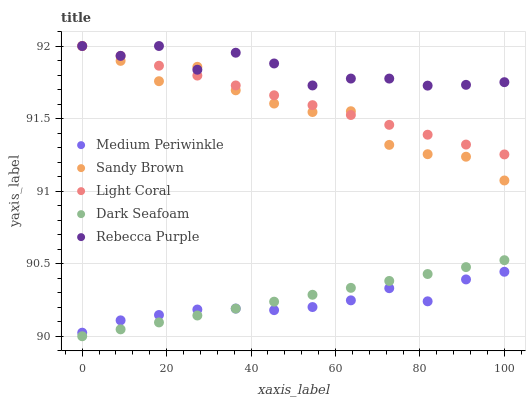Does Medium Periwinkle have the minimum area under the curve?
Answer yes or no. Yes. Does Rebecca Purple have the maximum area under the curve?
Answer yes or no. Yes. Does Sandy Brown have the minimum area under the curve?
Answer yes or no. No. Does Sandy Brown have the maximum area under the curve?
Answer yes or no. No. Is Dark Seafoam the smoothest?
Answer yes or no. Yes. Is Sandy Brown the roughest?
Answer yes or no. Yes. Is Sandy Brown the smoothest?
Answer yes or no. No. Is Dark Seafoam the roughest?
Answer yes or no. No. Does Dark Seafoam have the lowest value?
Answer yes or no. Yes. Does Sandy Brown have the lowest value?
Answer yes or no. No. Does Rebecca Purple have the highest value?
Answer yes or no. Yes. Does Dark Seafoam have the highest value?
Answer yes or no. No. Is Dark Seafoam less than Light Coral?
Answer yes or no. Yes. Is Sandy Brown greater than Dark Seafoam?
Answer yes or no. Yes. Does Light Coral intersect Rebecca Purple?
Answer yes or no. Yes. Is Light Coral less than Rebecca Purple?
Answer yes or no. No. Is Light Coral greater than Rebecca Purple?
Answer yes or no. No. Does Dark Seafoam intersect Light Coral?
Answer yes or no. No. 